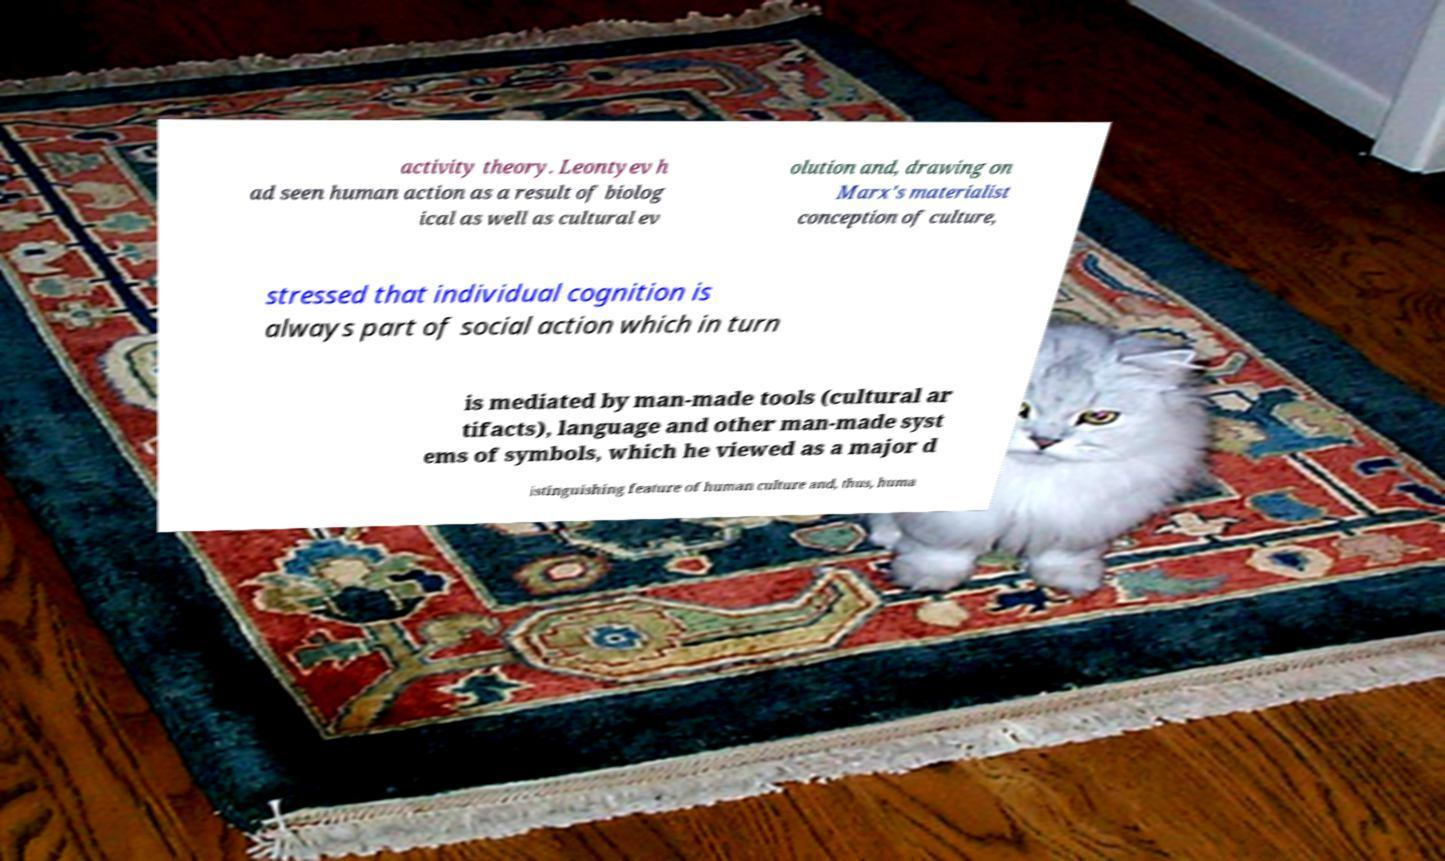Can you accurately transcribe the text from the provided image for me? activity theory. Leontyev h ad seen human action as a result of biolog ical as well as cultural ev olution and, drawing on Marx's materialist conception of culture, stressed that individual cognition is always part of social action which in turn is mediated by man-made tools (cultural ar tifacts), language and other man-made syst ems of symbols, which he viewed as a major d istinguishing feature of human culture and, thus, huma 